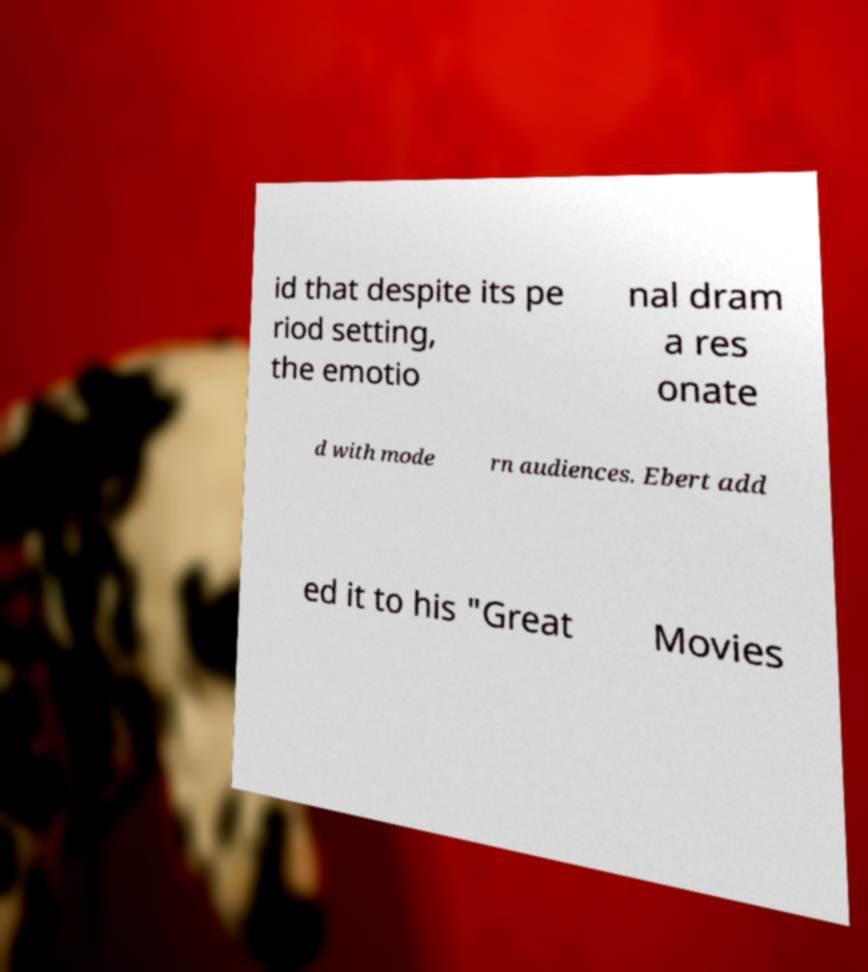What messages or text are displayed in this image? I need them in a readable, typed format. id that despite its pe riod setting, the emotio nal dram a res onate d with mode rn audiences. Ebert add ed it to his "Great Movies 